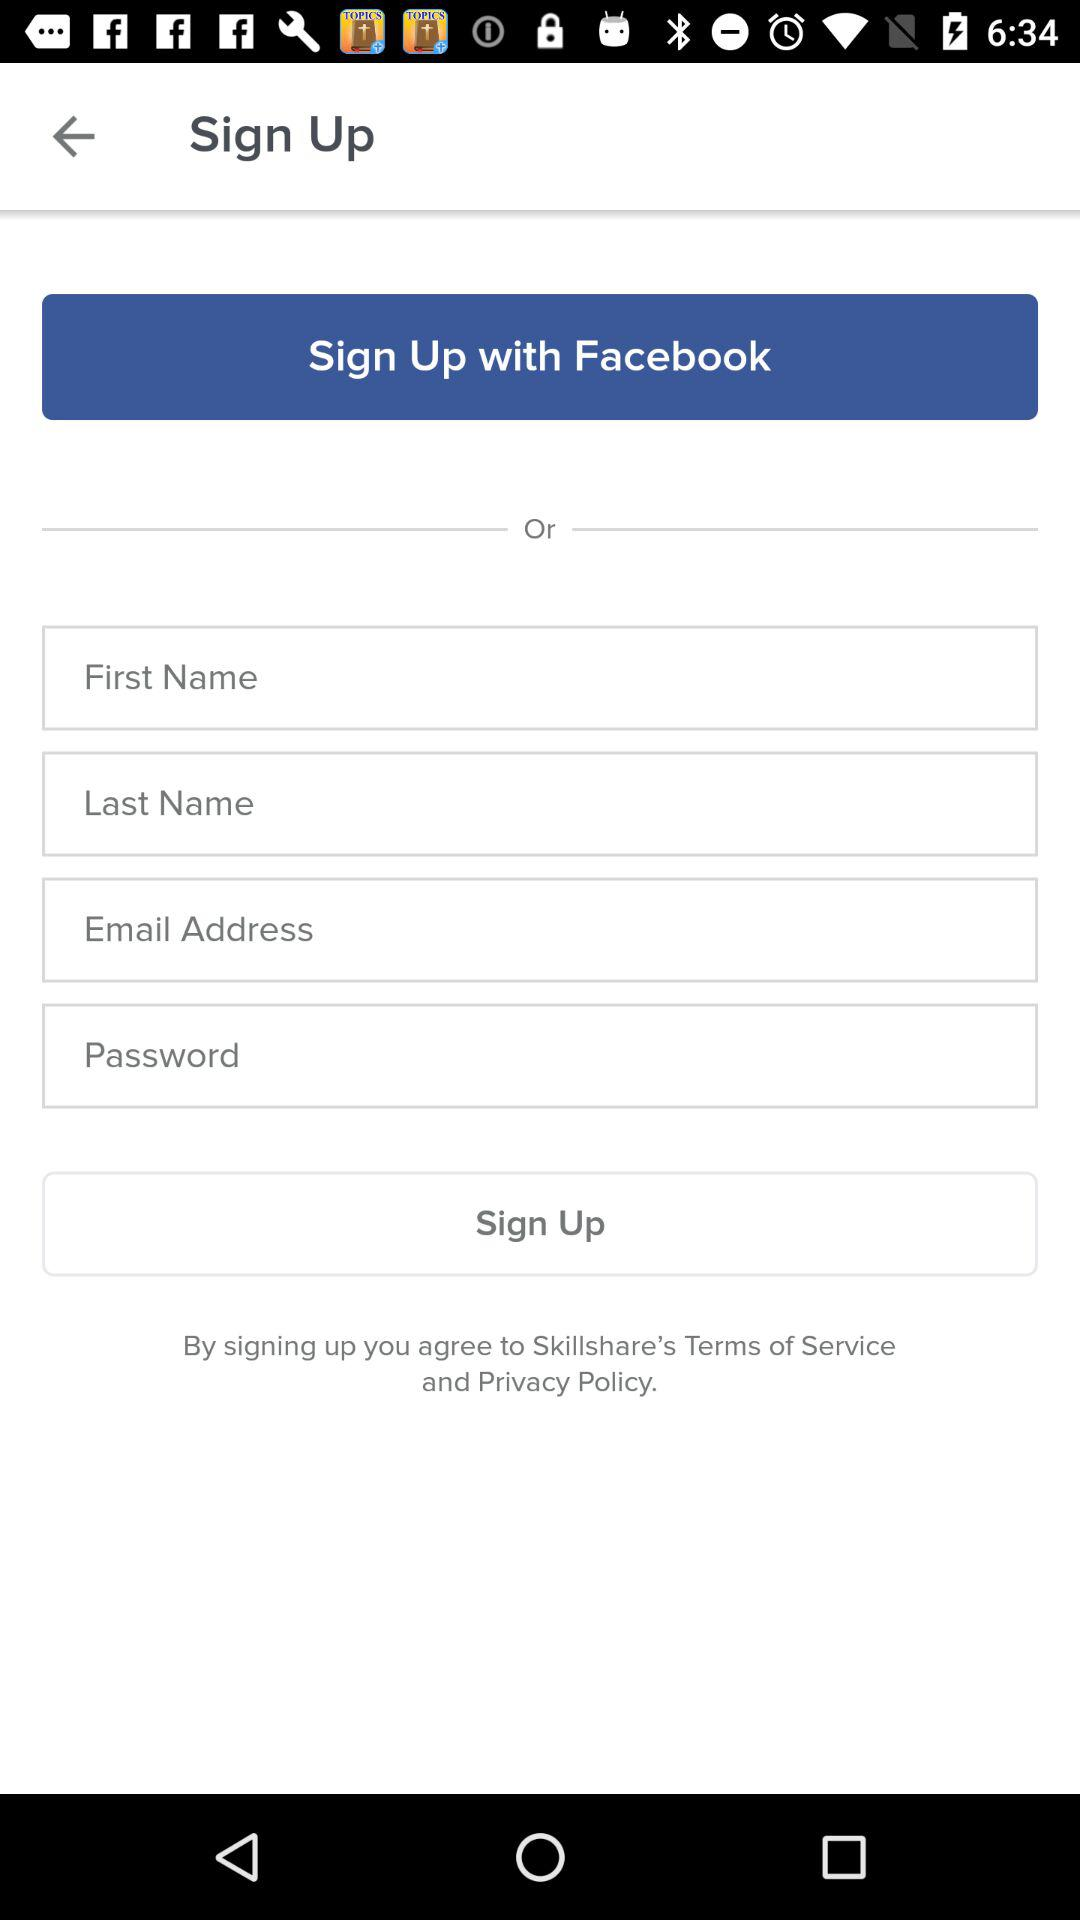How many text inputs are there for signing up?
Answer the question using a single word or phrase. 4 